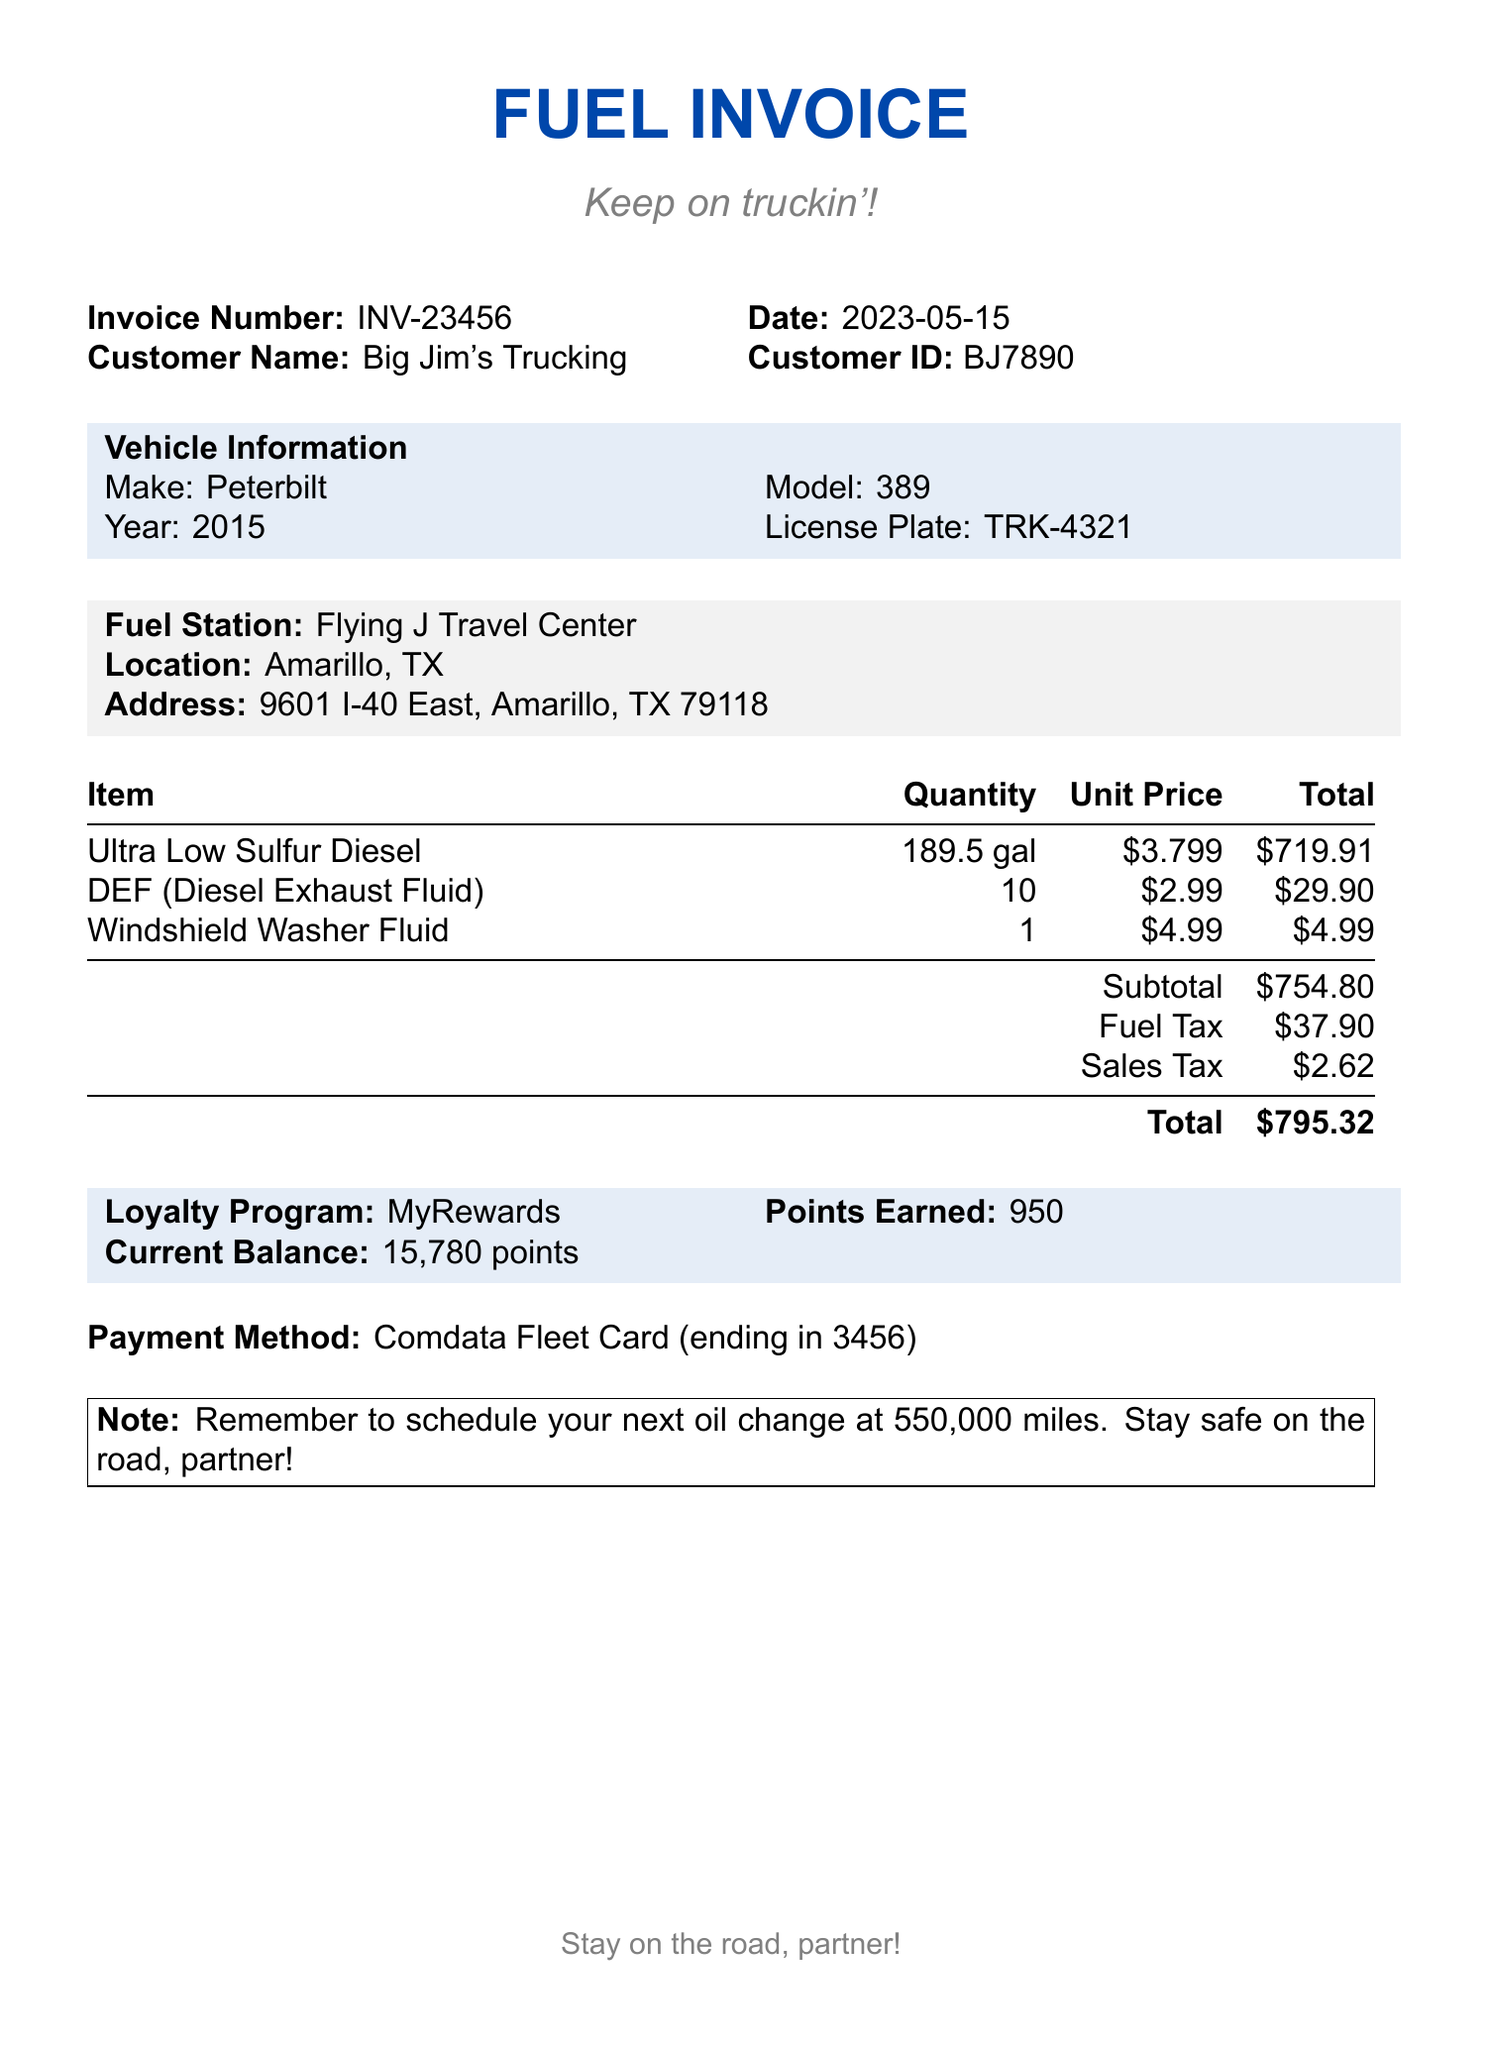What is the invoice number? The invoice number is listed at the top right of the document.
Answer: INV-23456 What is the total amount due? The total amount is the final sum stated at the bottom of the invoice.
Answer: $795.32 How many gallons of diesel were purchased? The total gallons filled is mentioned in the fuel details section.
Answer: 189.5 What is the price per gallon of diesel? The price per gallon is stated alongside the total gallons in the fuel details.
Answer: $3.799 What loyalty program is associated with this invoice? The loyalty program name is provided in the loyalty program section.
Answer: MyRewards What is the payment method used? The payment method is clearly stated in the payment method section.
Answer: Comdata Fleet Card How much was spent on Diesel Exhaust Fluid? The total for Diesel Exhaust Fluid can be found in the additional items section.
Answer: $29.90 What tax was charged on the fuel? Both fuel tax and sales tax are mentioned separately in the taxes section.
Answer: $37.90 What is the license plate of the vehicle? The license plate information is found in the vehicle information section of the document.
Answer: TRK-4321 